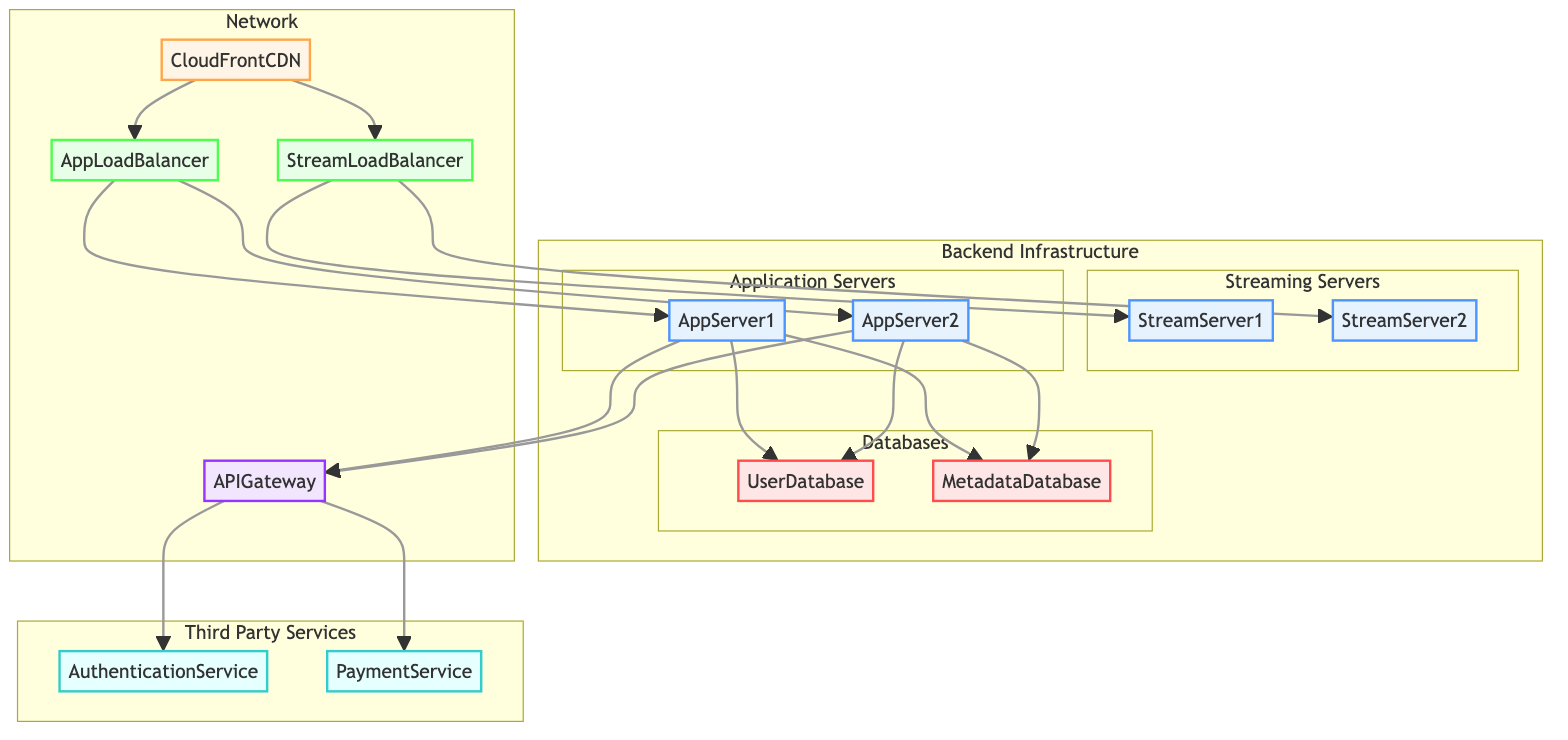What's the number of application servers? There are two nodes labeled AppServer1 and AppServer2 under the Application Servers subgraph, indicating the total count of application servers present in the diagram.
Answer: 2 What type of database is UserDatabase? The UserDatabase is specifically labeled as Amazon RDS and is noted to use MySQL as its engine, which directly points to its type represented in the diagram.
Answer: Amazon RDS How many total load balancers are present in the diagram? The diagram includes two nodes, AppLoadBalancer and StreamLoadBalancer, categorized under the Network section. Thus, the total number of load balancers can be counted directly from these nodes.
Answer: 2 Which server type is used for streaming? The nodes labeled StreamServer1 and StreamServer2 are both described as Wowza Streaming Engine, indicating the specific type of server responsible for streaming in the setup.
Answer: Wowza Streaming Engine What is the role of the API Gateway? The APIGateway node in the diagram connects the application servers to third-party services, indicating its role primarily as a bridge for APIs, thus facilitating communication between various components.
Answer: Bridge for APIs Which two services integrate for payment processing? The diagram indicates that the PaymentService node is labeled as Stripe and located under the Third Party Services section, highlighting its specific role among third-party integrations and services.
Answer: Stripe What connection exists between the CloudFrontCDN and AppLoadBalancer? In the diagram, an arrow points from CloudFrontCDN to AppLoadBalancer, indicating a direct relationship where CloudFrontCDN sends content to the AppLoadBalancer, forming a clear flow of data.
Answer: Direct connection Which zone encompasses the CloudFrontCDN? The CloudFrontCDN node in the diagram is explicitly labeled as having a global zone, thus indicating that it operates on a worldwide scale rather than being limited to a specific region.
Answer: Global 